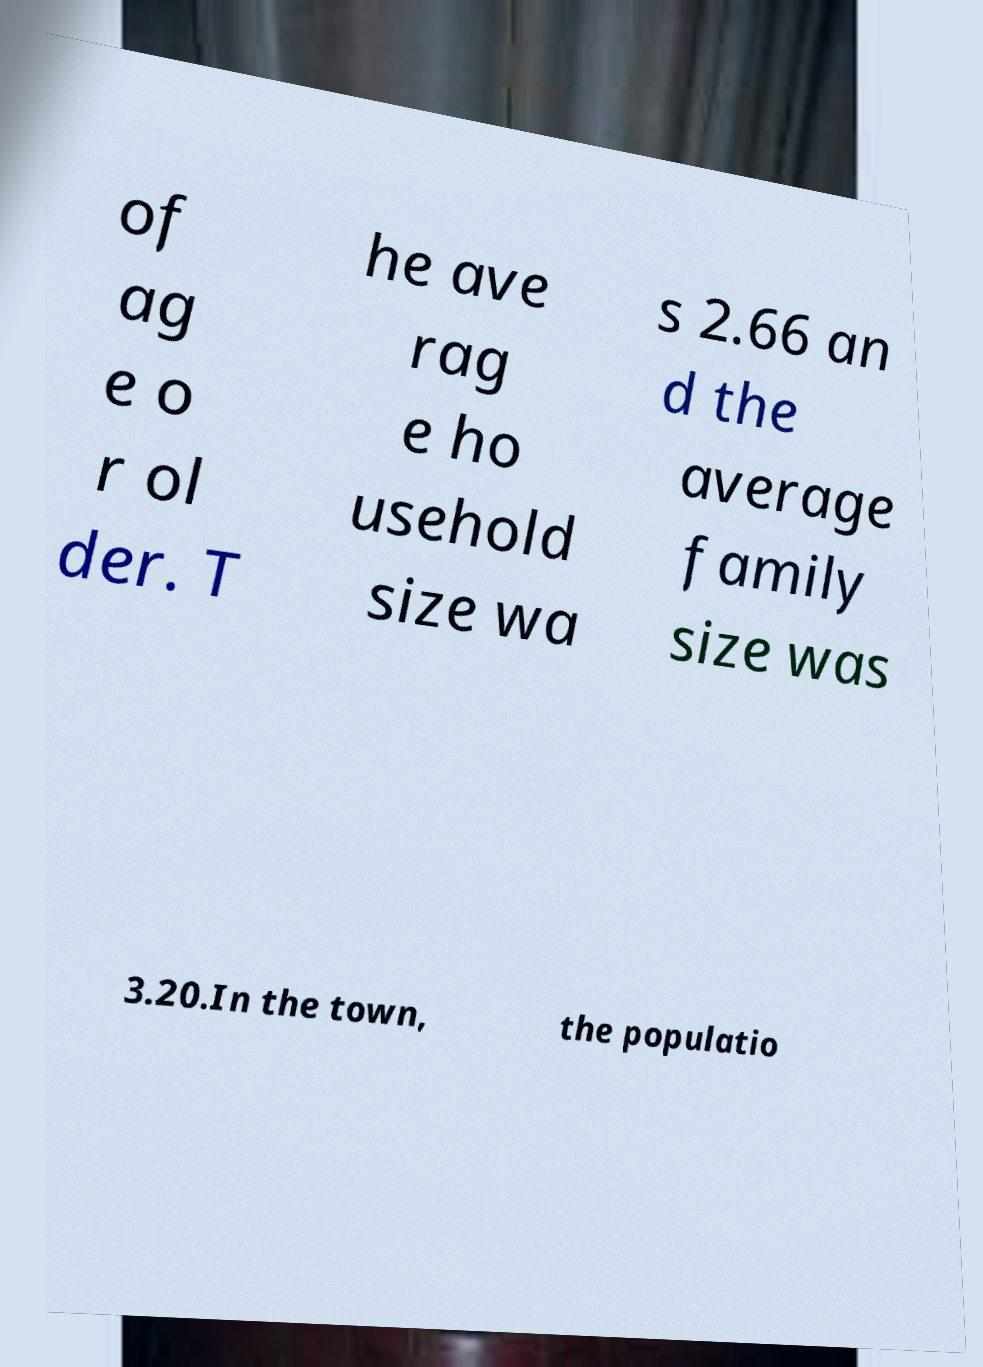Could you assist in decoding the text presented in this image and type it out clearly? of ag e o r ol der. T he ave rag e ho usehold size wa s 2.66 an d the average family size was 3.20.In the town, the populatio 